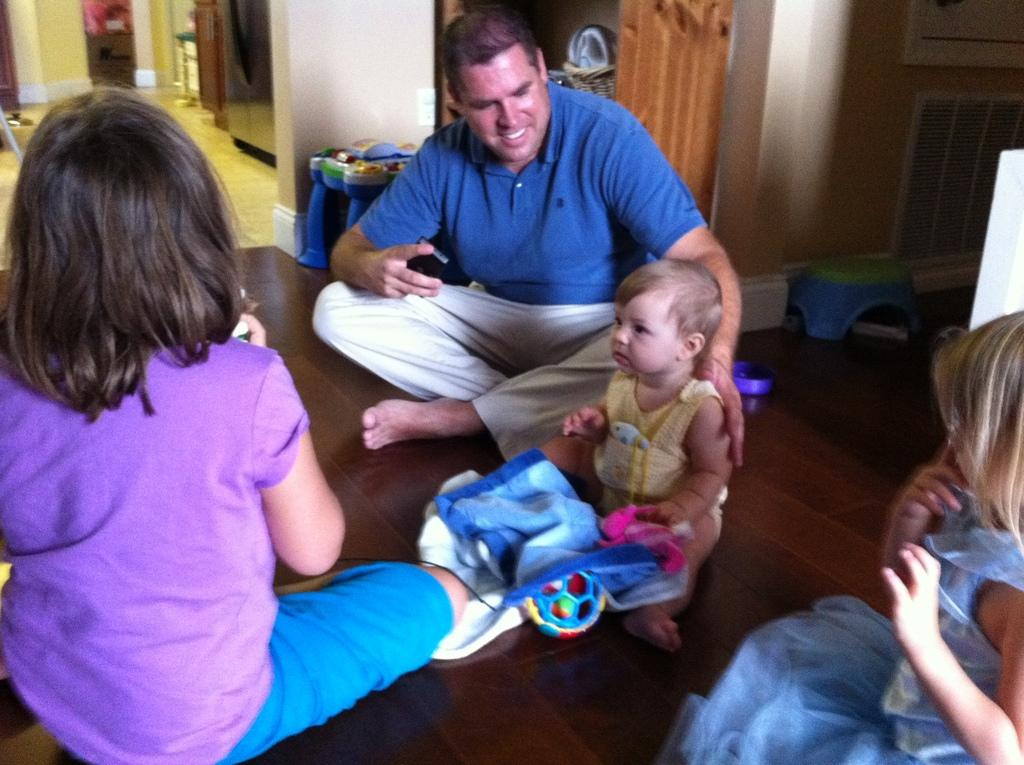What are the people in the image doing? There is a group of people sitting on the floor. What else can be seen on the floor besides the people? There are objects on the floor. What can be seen in the background of the image? There is a wall visible in the background, and there appears to be a fridge in the background. What type of texture can be seen on the celery in the image? There is no celery present in the image, so it is not possible to determine the texture of any celery. 